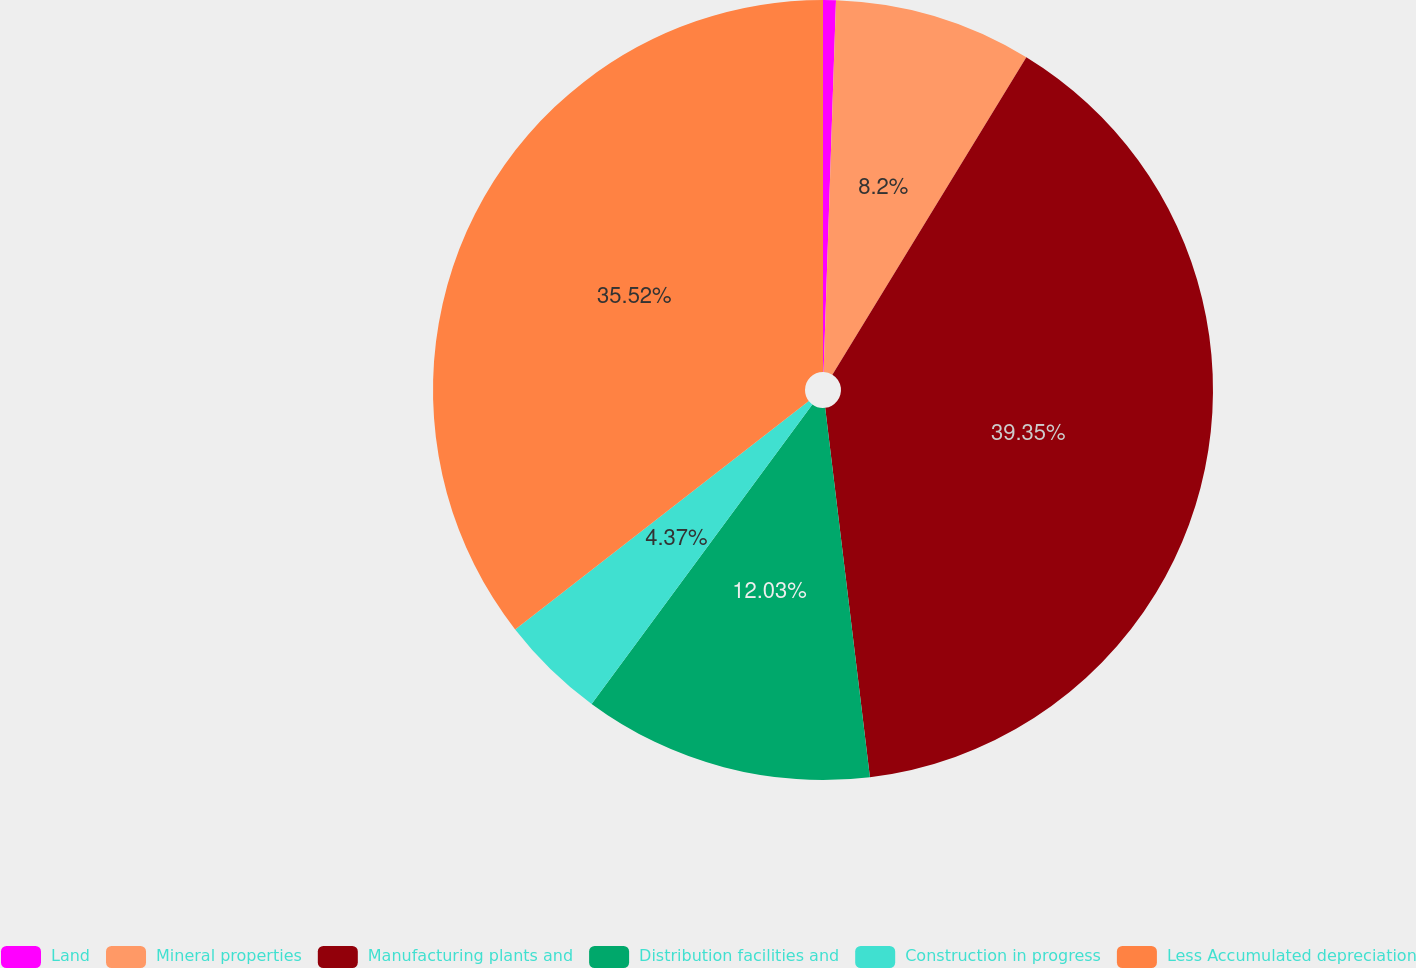<chart> <loc_0><loc_0><loc_500><loc_500><pie_chart><fcel>Land<fcel>Mineral properties<fcel>Manufacturing plants and<fcel>Distribution facilities and<fcel>Construction in progress<fcel>Less Accumulated depreciation<nl><fcel>0.53%<fcel>8.2%<fcel>39.35%<fcel>12.03%<fcel>4.37%<fcel>35.52%<nl></chart> 